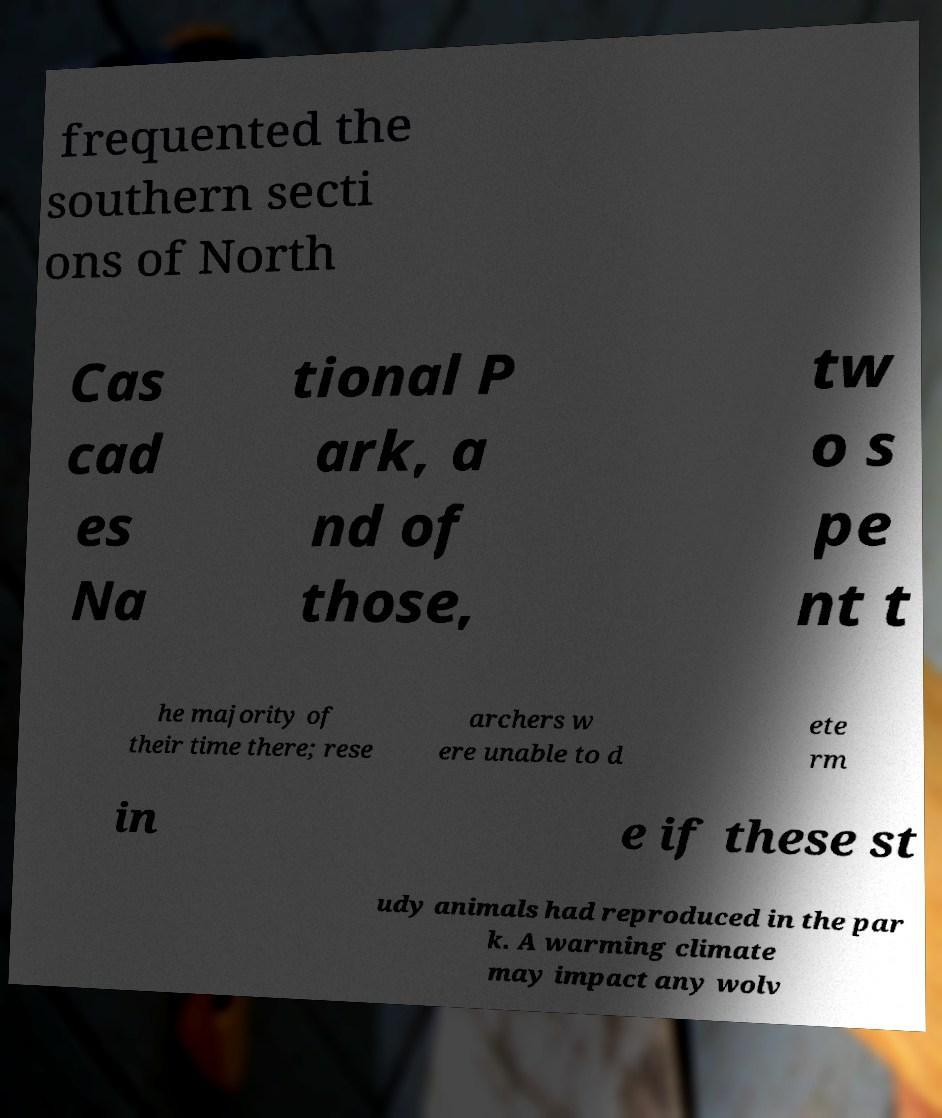I need the written content from this picture converted into text. Can you do that? frequented the southern secti ons of North Cas cad es Na tional P ark, a nd of those, tw o s pe nt t he majority of their time there; rese archers w ere unable to d ete rm in e if these st udy animals had reproduced in the par k. A warming climate may impact any wolv 